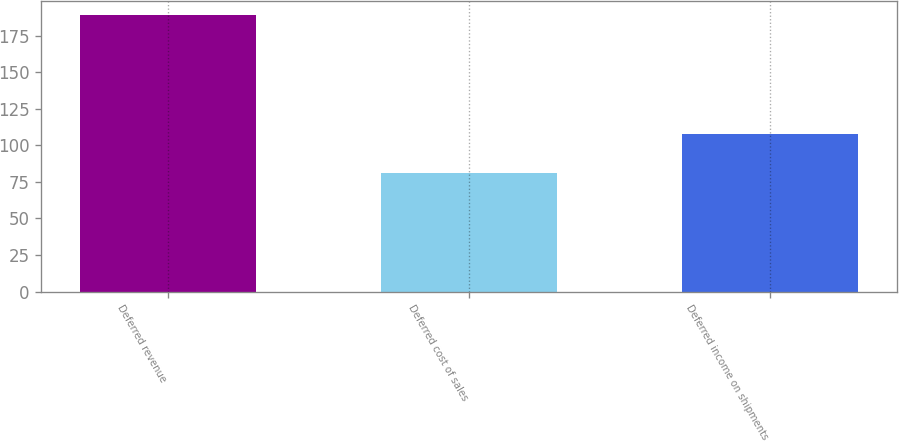Convert chart. <chart><loc_0><loc_0><loc_500><loc_500><bar_chart><fcel>Deferred revenue<fcel>Deferred cost of sales<fcel>Deferred income on shipments<nl><fcel>189<fcel>81<fcel>108<nl></chart> 